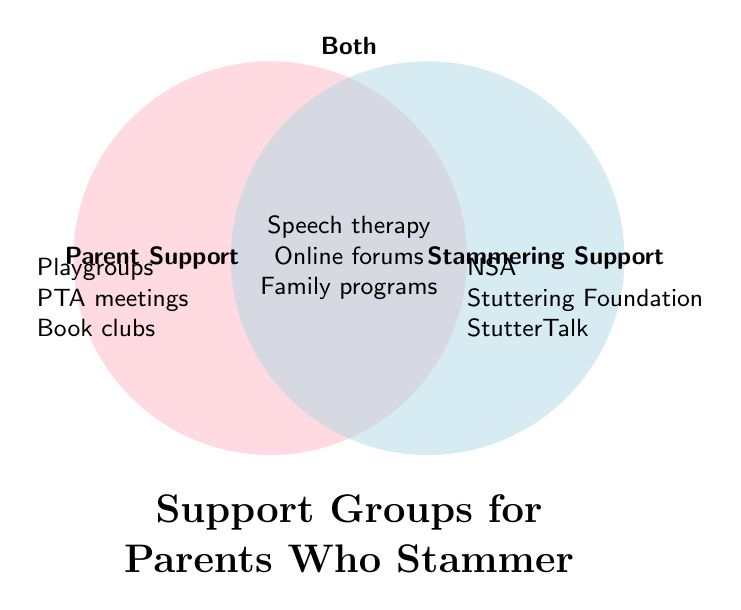What is the title of this Venn Diagram? The title is the text found at the top or middle explaining the diagram's subject. In this case, it is found at the bottom center of the diagram and states "Support Groups for Parents Who Stammer".
Answer: Support Groups for Parents Who Stammer Which support groups are listed under "Parent Support" only? The groups listed under "Parent Support" only are those on the left side of the diagram, specifically: "Playgroups", "PTA meetings", and "Book clubs".
Answer: Playgroups, PTA meetings, Book clubs What are the names of the support groups that appear in both categories, "Parent Support" and "Stammering Support"? The names in the overlapping central area are the ones that support both categories. These are: "Speech therapy", "Online forums", and "Family programs".
Answer: Speech therapy, Online forums, Family programs Which side of the Venn Diagram has more groups, "Parent Support" or "Stammering Support"? To answer this, count the groups in both exclusive sections. "Parent Support" has 3 groups while "Stammering Support" has 3 groups. Since they are equal, neither side has more groups.
Answer: Equal How many total different support groups are listed in the Venn Diagram? Add the number of groups in "Parent Support" (3), "Stammering Support" (3), and both (3). The total number is 3 + 3 + 3.
Answer: 9 Which side or section includes the "Stuttering Foundation"? The "Stuttering Foundation" is specifically listed under "Stammering Support" located on the right-hand side of the Venn Diagram.
Answer: Stammering Support Describe the process to find if any support group appears in all three categories simultaneously. As this is a Venn Diagram with only two categories, there is no third category. Thus, there can be no support group appearing in all three categories.
Answer: None Which support group appears in the section labeled "Both" and also promotes parent-child social events? Look in the "Both" category in the center and identify the group. According to the list, "Parent-child social events" falls under this category.
Answer: Parent-child social events 